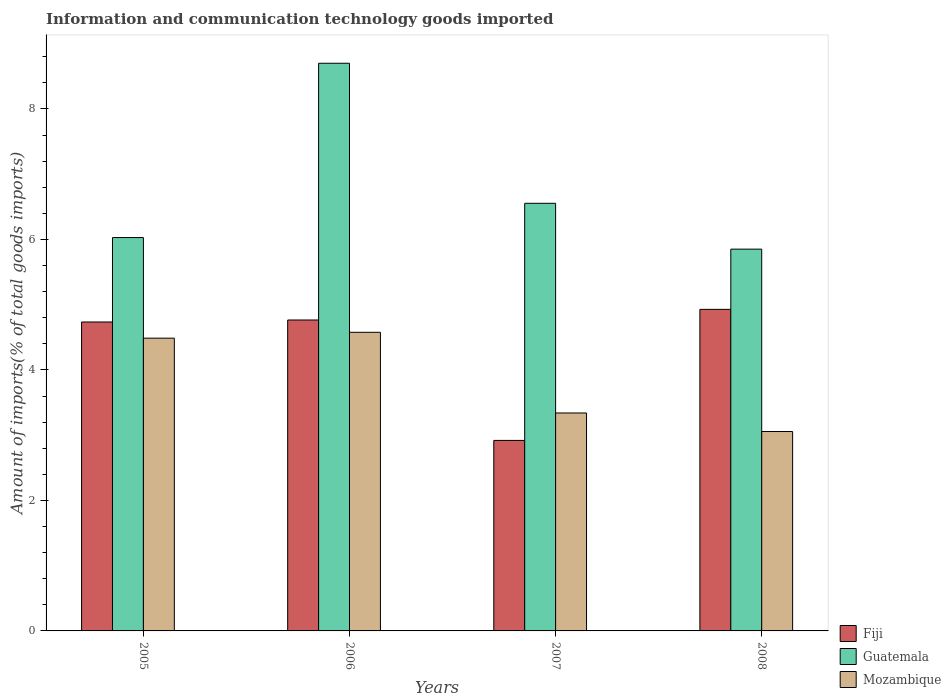How many different coloured bars are there?
Your answer should be very brief. 3. Are the number of bars on each tick of the X-axis equal?
Your response must be concise. Yes. How many bars are there on the 3rd tick from the left?
Your response must be concise. 3. What is the label of the 2nd group of bars from the left?
Provide a succinct answer. 2006. In how many cases, is the number of bars for a given year not equal to the number of legend labels?
Give a very brief answer. 0. What is the amount of goods imported in Guatemala in 2005?
Provide a succinct answer. 6.03. Across all years, what is the maximum amount of goods imported in Mozambique?
Your response must be concise. 4.58. Across all years, what is the minimum amount of goods imported in Fiji?
Provide a succinct answer. 2.92. In which year was the amount of goods imported in Guatemala maximum?
Your answer should be very brief. 2006. In which year was the amount of goods imported in Mozambique minimum?
Offer a very short reply. 2008. What is the total amount of goods imported in Guatemala in the graph?
Your answer should be compact. 27.13. What is the difference between the amount of goods imported in Mozambique in 2005 and that in 2007?
Make the answer very short. 1.15. What is the difference between the amount of goods imported in Mozambique in 2008 and the amount of goods imported in Guatemala in 2005?
Offer a very short reply. -2.97. What is the average amount of goods imported in Mozambique per year?
Make the answer very short. 3.87. In the year 2008, what is the difference between the amount of goods imported in Mozambique and amount of goods imported in Guatemala?
Ensure brevity in your answer.  -2.8. In how many years, is the amount of goods imported in Fiji greater than 6.4 %?
Offer a terse response. 0. What is the ratio of the amount of goods imported in Fiji in 2006 to that in 2008?
Your answer should be compact. 0.97. Is the difference between the amount of goods imported in Mozambique in 2006 and 2007 greater than the difference between the amount of goods imported in Guatemala in 2006 and 2007?
Provide a succinct answer. No. What is the difference between the highest and the second highest amount of goods imported in Guatemala?
Ensure brevity in your answer.  2.15. What is the difference between the highest and the lowest amount of goods imported in Fiji?
Keep it short and to the point. 2.01. Is the sum of the amount of goods imported in Fiji in 2007 and 2008 greater than the maximum amount of goods imported in Mozambique across all years?
Ensure brevity in your answer.  Yes. What does the 3rd bar from the left in 2008 represents?
Offer a terse response. Mozambique. What does the 1st bar from the right in 2005 represents?
Your answer should be very brief. Mozambique. Are all the bars in the graph horizontal?
Offer a very short reply. No. How many years are there in the graph?
Your response must be concise. 4. What is the difference between two consecutive major ticks on the Y-axis?
Keep it short and to the point. 2. Does the graph contain any zero values?
Your response must be concise. No. Where does the legend appear in the graph?
Keep it short and to the point. Bottom right. How are the legend labels stacked?
Offer a terse response. Vertical. What is the title of the graph?
Your answer should be very brief. Information and communication technology goods imported. Does "Sint Maarten (Dutch part)" appear as one of the legend labels in the graph?
Keep it short and to the point. No. What is the label or title of the X-axis?
Keep it short and to the point. Years. What is the label or title of the Y-axis?
Offer a very short reply. Amount of imports(% of total goods imports). What is the Amount of imports(% of total goods imports) of Fiji in 2005?
Your answer should be very brief. 4.73. What is the Amount of imports(% of total goods imports) of Guatemala in 2005?
Ensure brevity in your answer.  6.03. What is the Amount of imports(% of total goods imports) of Mozambique in 2005?
Give a very brief answer. 4.49. What is the Amount of imports(% of total goods imports) of Fiji in 2006?
Offer a terse response. 4.77. What is the Amount of imports(% of total goods imports) of Guatemala in 2006?
Give a very brief answer. 8.7. What is the Amount of imports(% of total goods imports) of Mozambique in 2006?
Your answer should be compact. 4.58. What is the Amount of imports(% of total goods imports) of Fiji in 2007?
Provide a succinct answer. 2.92. What is the Amount of imports(% of total goods imports) in Guatemala in 2007?
Provide a succinct answer. 6.55. What is the Amount of imports(% of total goods imports) of Mozambique in 2007?
Give a very brief answer. 3.34. What is the Amount of imports(% of total goods imports) in Fiji in 2008?
Keep it short and to the point. 4.93. What is the Amount of imports(% of total goods imports) in Guatemala in 2008?
Offer a very short reply. 5.85. What is the Amount of imports(% of total goods imports) of Mozambique in 2008?
Offer a terse response. 3.06. Across all years, what is the maximum Amount of imports(% of total goods imports) of Fiji?
Your answer should be compact. 4.93. Across all years, what is the maximum Amount of imports(% of total goods imports) of Guatemala?
Provide a short and direct response. 8.7. Across all years, what is the maximum Amount of imports(% of total goods imports) in Mozambique?
Keep it short and to the point. 4.58. Across all years, what is the minimum Amount of imports(% of total goods imports) in Fiji?
Your response must be concise. 2.92. Across all years, what is the minimum Amount of imports(% of total goods imports) in Guatemala?
Give a very brief answer. 5.85. Across all years, what is the minimum Amount of imports(% of total goods imports) of Mozambique?
Your response must be concise. 3.06. What is the total Amount of imports(% of total goods imports) of Fiji in the graph?
Provide a succinct answer. 17.35. What is the total Amount of imports(% of total goods imports) in Guatemala in the graph?
Offer a terse response. 27.13. What is the total Amount of imports(% of total goods imports) of Mozambique in the graph?
Your answer should be compact. 15.46. What is the difference between the Amount of imports(% of total goods imports) of Fiji in 2005 and that in 2006?
Offer a terse response. -0.03. What is the difference between the Amount of imports(% of total goods imports) in Guatemala in 2005 and that in 2006?
Make the answer very short. -2.67. What is the difference between the Amount of imports(% of total goods imports) of Mozambique in 2005 and that in 2006?
Offer a very short reply. -0.09. What is the difference between the Amount of imports(% of total goods imports) in Fiji in 2005 and that in 2007?
Offer a very short reply. 1.82. What is the difference between the Amount of imports(% of total goods imports) of Guatemala in 2005 and that in 2007?
Provide a succinct answer. -0.53. What is the difference between the Amount of imports(% of total goods imports) in Mozambique in 2005 and that in 2007?
Ensure brevity in your answer.  1.15. What is the difference between the Amount of imports(% of total goods imports) of Fiji in 2005 and that in 2008?
Keep it short and to the point. -0.19. What is the difference between the Amount of imports(% of total goods imports) in Guatemala in 2005 and that in 2008?
Your response must be concise. 0.18. What is the difference between the Amount of imports(% of total goods imports) of Mozambique in 2005 and that in 2008?
Your response must be concise. 1.43. What is the difference between the Amount of imports(% of total goods imports) in Fiji in 2006 and that in 2007?
Provide a succinct answer. 1.85. What is the difference between the Amount of imports(% of total goods imports) in Guatemala in 2006 and that in 2007?
Provide a succinct answer. 2.15. What is the difference between the Amount of imports(% of total goods imports) of Mozambique in 2006 and that in 2007?
Offer a very short reply. 1.24. What is the difference between the Amount of imports(% of total goods imports) of Fiji in 2006 and that in 2008?
Keep it short and to the point. -0.16. What is the difference between the Amount of imports(% of total goods imports) in Guatemala in 2006 and that in 2008?
Your answer should be very brief. 2.85. What is the difference between the Amount of imports(% of total goods imports) of Mozambique in 2006 and that in 2008?
Make the answer very short. 1.52. What is the difference between the Amount of imports(% of total goods imports) in Fiji in 2007 and that in 2008?
Provide a short and direct response. -2.01. What is the difference between the Amount of imports(% of total goods imports) in Guatemala in 2007 and that in 2008?
Provide a short and direct response. 0.7. What is the difference between the Amount of imports(% of total goods imports) of Mozambique in 2007 and that in 2008?
Your answer should be very brief. 0.28. What is the difference between the Amount of imports(% of total goods imports) of Fiji in 2005 and the Amount of imports(% of total goods imports) of Guatemala in 2006?
Ensure brevity in your answer.  -3.97. What is the difference between the Amount of imports(% of total goods imports) in Fiji in 2005 and the Amount of imports(% of total goods imports) in Mozambique in 2006?
Offer a very short reply. 0.16. What is the difference between the Amount of imports(% of total goods imports) in Guatemala in 2005 and the Amount of imports(% of total goods imports) in Mozambique in 2006?
Make the answer very short. 1.45. What is the difference between the Amount of imports(% of total goods imports) in Fiji in 2005 and the Amount of imports(% of total goods imports) in Guatemala in 2007?
Provide a short and direct response. -1.82. What is the difference between the Amount of imports(% of total goods imports) in Fiji in 2005 and the Amount of imports(% of total goods imports) in Mozambique in 2007?
Provide a short and direct response. 1.39. What is the difference between the Amount of imports(% of total goods imports) of Guatemala in 2005 and the Amount of imports(% of total goods imports) of Mozambique in 2007?
Provide a succinct answer. 2.69. What is the difference between the Amount of imports(% of total goods imports) in Fiji in 2005 and the Amount of imports(% of total goods imports) in Guatemala in 2008?
Your answer should be compact. -1.12. What is the difference between the Amount of imports(% of total goods imports) of Fiji in 2005 and the Amount of imports(% of total goods imports) of Mozambique in 2008?
Offer a very short reply. 1.68. What is the difference between the Amount of imports(% of total goods imports) in Guatemala in 2005 and the Amount of imports(% of total goods imports) in Mozambique in 2008?
Ensure brevity in your answer.  2.97. What is the difference between the Amount of imports(% of total goods imports) of Fiji in 2006 and the Amount of imports(% of total goods imports) of Guatemala in 2007?
Your response must be concise. -1.79. What is the difference between the Amount of imports(% of total goods imports) of Fiji in 2006 and the Amount of imports(% of total goods imports) of Mozambique in 2007?
Keep it short and to the point. 1.43. What is the difference between the Amount of imports(% of total goods imports) in Guatemala in 2006 and the Amount of imports(% of total goods imports) in Mozambique in 2007?
Your response must be concise. 5.36. What is the difference between the Amount of imports(% of total goods imports) of Fiji in 2006 and the Amount of imports(% of total goods imports) of Guatemala in 2008?
Give a very brief answer. -1.09. What is the difference between the Amount of imports(% of total goods imports) of Fiji in 2006 and the Amount of imports(% of total goods imports) of Mozambique in 2008?
Offer a very short reply. 1.71. What is the difference between the Amount of imports(% of total goods imports) in Guatemala in 2006 and the Amount of imports(% of total goods imports) in Mozambique in 2008?
Your response must be concise. 5.64. What is the difference between the Amount of imports(% of total goods imports) of Fiji in 2007 and the Amount of imports(% of total goods imports) of Guatemala in 2008?
Provide a succinct answer. -2.93. What is the difference between the Amount of imports(% of total goods imports) of Fiji in 2007 and the Amount of imports(% of total goods imports) of Mozambique in 2008?
Keep it short and to the point. -0.14. What is the difference between the Amount of imports(% of total goods imports) in Guatemala in 2007 and the Amount of imports(% of total goods imports) in Mozambique in 2008?
Keep it short and to the point. 3.5. What is the average Amount of imports(% of total goods imports) in Fiji per year?
Keep it short and to the point. 4.34. What is the average Amount of imports(% of total goods imports) of Guatemala per year?
Keep it short and to the point. 6.78. What is the average Amount of imports(% of total goods imports) of Mozambique per year?
Your answer should be very brief. 3.87. In the year 2005, what is the difference between the Amount of imports(% of total goods imports) in Fiji and Amount of imports(% of total goods imports) in Guatemala?
Your response must be concise. -1.29. In the year 2005, what is the difference between the Amount of imports(% of total goods imports) of Fiji and Amount of imports(% of total goods imports) of Mozambique?
Your answer should be compact. 0.25. In the year 2005, what is the difference between the Amount of imports(% of total goods imports) in Guatemala and Amount of imports(% of total goods imports) in Mozambique?
Your answer should be very brief. 1.54. In the year 2006, what is the difference between the Amount of imports(% of total goods imports) in Fiji and Amount of imports(% of total goods imports) in Guatemala?
Your response must be concise. -3.93. In the year 2006, what is the difference between the Amount of imports(% of total goods imports) in Fiji and Amount of imports(% of total goods imports) in Mozambique?
Offer a terse response. 0.19. In the year 2006, what is the difference between the Amount of imports(% of total goods imports) in Guatemala and Amount of imports(% of total goods imports) in Mozambique?
Ensure brevity in your answer.  4.12. In the year 2007, what is the difference between the Amount of imports(% of total goods imports) in Fiji and Amount of imports(% of total goods imports) in Guatemala?
Offer a very short reply. -3.63. In the year 2007, what is the difference between the Amount of imports(% of total goods imports) of Fiji and Amount of imports(% of total goods imports) of Mozambique?
Give a very brief answer. -0.42. In the year 2007, what is the difference between the Amount of imports(% of total goods imports) in Guatemala and Amount of imports(% of total goods imports) in Mozambique?
Ensure brevity in your answer.  3.21. In the year 2008, what is the difference between the Amount of imports(% of total goods imports) in Fiji and Amount of imports(% of total goods imports) in Guatemala?
Offer a terse response. -0.92. In the year 2008, what is the difference between the Amount of imports(% of total goods imports) in Fiji and Amount of imports(% of total goods imports) in Mozambique?
Provide a short and direct response. 1.87. In the year 2008, what is the difference between the Amount of imports(% of total goods imports) in Guatemala and Amount of imports(% of total goods imports) in Mozambique?
Provide a short and direct response. 2.8. What is the ratio of the Amount of imports(% of total goods imports) in Guatemala in 2005 to that in 2006?
Provide a short and direct response. 0.69. What is the ratio of the Amount of imports(% of total goods imports) in Mozambique in 2005 to that in 2006?
Your answer should be very brief. 0.98. What is the ratio of the Amount of imports(% of total goods imports) in Fiji in 2005 to that in 2007?
Your answer should be compact. 1.62. What is the ratio of the Amount of imports(% of total goods imports) of Guatemala in 2005 to that in 2007?
Provide a succinct answer. 0.92. What is the ratio of the Amount of imports(% of total goods imports) in Mozambique in 2005 to that in 2007?
Give a very brief answer. 1.34. What is the ratio of the Amount of imports(% of total goods imports) of Fiji in 2005 to that in 2008?
Your answer should be compact. 0.96. What is the ratio of the Amount of imports(% of total goods imports) of Guatemala in 2005 to that in 2008?
Ensure brevity in your answer.  1.03. What is the ratio of the Amount of imports(% of total goods imports) in Mozambique in 2005 to that in 2008?
Ensure brevity in your answer.  1.47. What is the ratio of the Amount of imports(% of total goods imports) in Fiji in 2006 to that in 2007?
Your answer should be compact. 1.63. What is the ratio of the Amount of imports(% of total goods imports) of Guatemala in 2006 to that in 2007?
Make the answer very short. 1.33. What is the ratio of the Amount of imports(% of total goods imports) in Mozambique in 2006 to that in 2007?
Provide a succinct answer. 1.37. What is the ratio of the Amount of imports(% of total goods imports) in Fiji in 2006 to that in 2008?
Provide a short and direct response. 0.97. What is the ratio of the Amount of imports(% of total goods imports) of Guatemala in 2006 to that in 2008?
Ensure brevity in your answer.  1.49. What is the ratio of the Amount of imports(% of total goods imports) in Mozambique in 2006 to that in 2008?
Your response must be concise. 1.5. What is the ratio of the Amount of imports(% of total goods imports) of Fiji in 2007 to that in 2008?
Make the answer very short. 0.59. What is the ratio of the Amount of imports(% of total goods imports) in Guatemala in 2007 to that in 2008?
Keep it short and to the point. 1.12. What is the ratio of the Amount of imports(% of total goods imports) in Mozambique in 2007 to that in 2008?
Make the answer very short. 1.09. What is the difference between the highest and the second highest Amount of imports(% of total goods imports) of Fiji?
Your response must be concise. 0.16. What is the difference between the highest and the second highest Amount of imports(% of total goods imports) of Guatemala?
Offer a terse response. 2.15. What is the difference between the highest and the second highest Amount of imports(% of total goods imports) of Mozambique?
Give a very brief answer. 0.09. What is the difference between the highest and the lowest Amount of imports(% of total goods imports) of Fiji?
Make the answer very short. 2.01. What is the difference between the highest and the lowest Amount of imports(% of total goods imports) in Guatemala?
Keep it short and to the point. 2.85. What is the difference between the highest and the lowest Amount of imports(% of total goods imports) of Mozambique?
Provide a succinct answer. 1.52. 